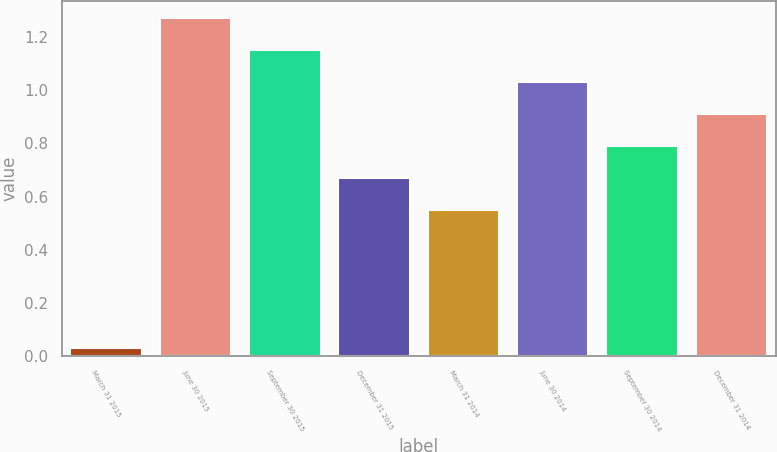<chart> <loc_0><loc_0><loc_500><loc_500><bar_chart><fcel>March 31 2015<fcel>June 30 2015<fcel>September 30 2015<fcel>December 31 2015<fcel>March 31 2014<fcel>June 30 2014<fcel>September 30 2014<fcel>December 31 2014<nl><fcel>0.03<fcel>1.27<fcel>1.15<fcel>0.67<fcel>0.55<fcel>1.03<fcel>0.79<fcel>0.91<nl></chart> 